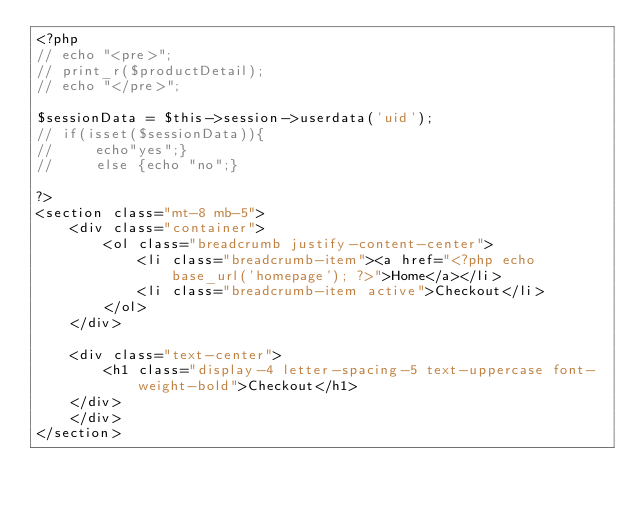<code> <loc_0><loc_0><loc_500><loc_500><_PHP_><?php
// echo "<pre>";
// print_r($productDetail);
// echo "</pre>";

$sessionData = $this->session->userdata('uid');
// if(isset($sessionData)){
//     echo"yes";}
//     else {echo "no";}

?>
<section class="mt-8 mb-5">
    <div class="container">
        <ol class="breadcrumb justify-content-center">
            <li class="breadcrumb-item"><a href="<?php echo base_url('homepage'); ?>">Home</a></li>
            <li class="breadcrumb-item active">Checkout</li>
        </ol>
    </div>

    <div class="text-center">
        <h1 class="display-4 letter-spacing-5 text-uppercase font-weight-bold">Checkout</h1>
    </div>
    </div>
</section></code> 